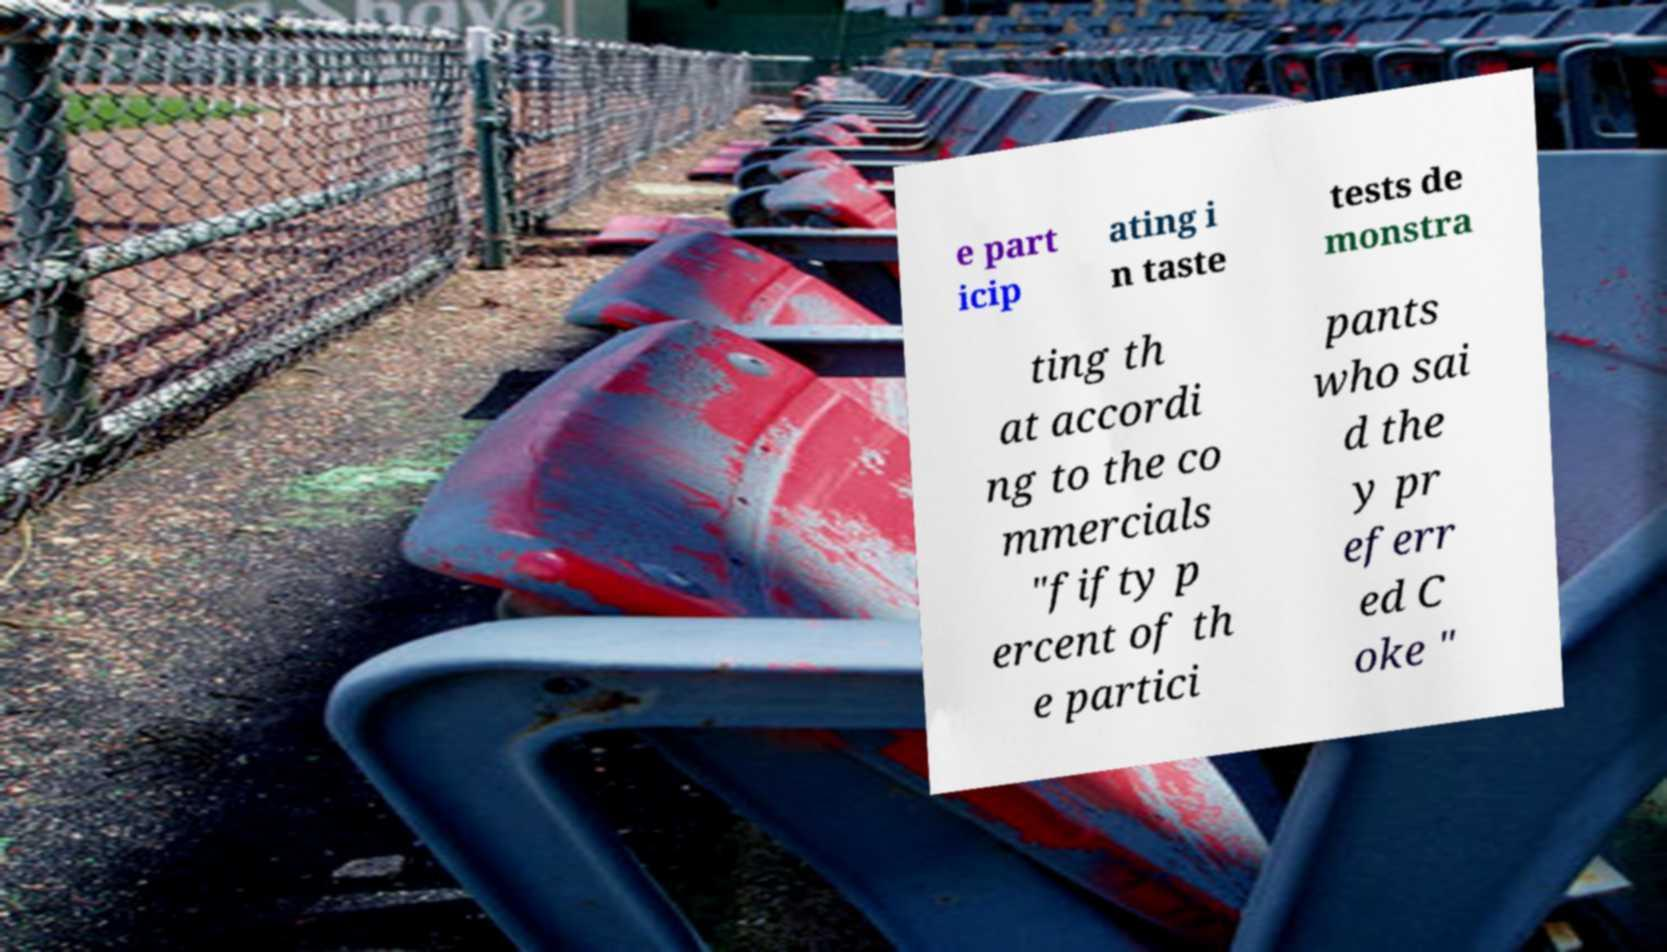Please read and relay the text visible in this image. What does it say? e part icip ating i n taste tests de monstra ting th at accordi ng to the co mmercials "fifty p ercent of th e partici pants who sai d the y pr eferr ed C oke " 